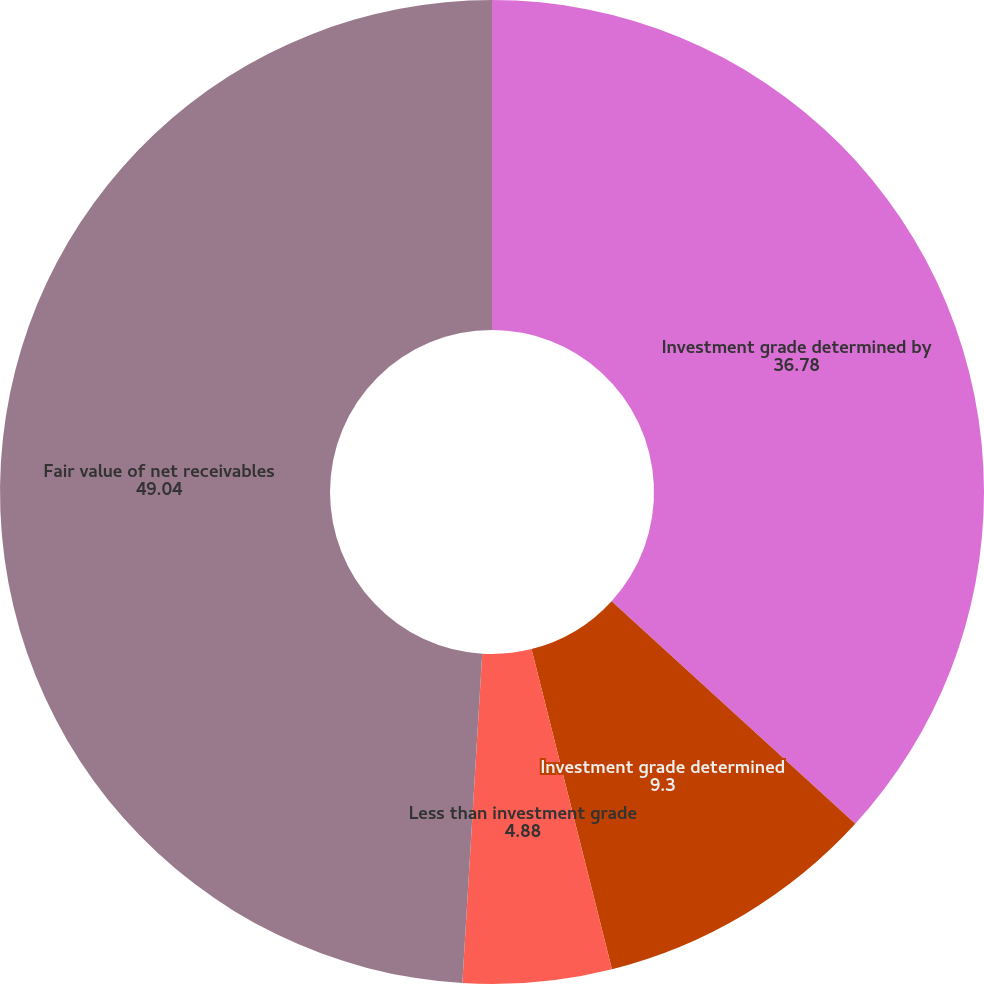Convert chart. <chart><loc_0><loc_0><loc_500><loc_500><pie_chart><fcel>Investment grade determined by<fcel>Investment grade determined<fcel>Less than investment grade<fcel>Fair value of net receivables<nl><fcel>36.78%<fcel>9.3%<fcel>4.88%<fcel>49.04%<nl></chart> 